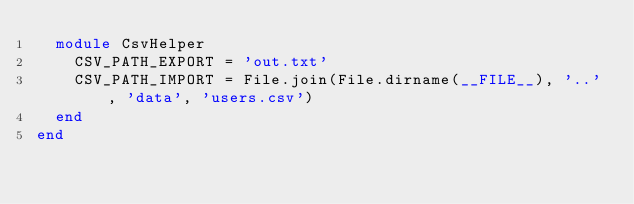Convert code to text. <code><loc_0><loc_0><loc_500><loc_500><_Ruby_>  module CsvHelper
    CSV_PATH_EXPORT = 'out.txt'
    CSV_PATH_IMPORT = File.join(File.dirname(__FILE__), '..', 'data', 'users.csv')
  end
end
</code> 